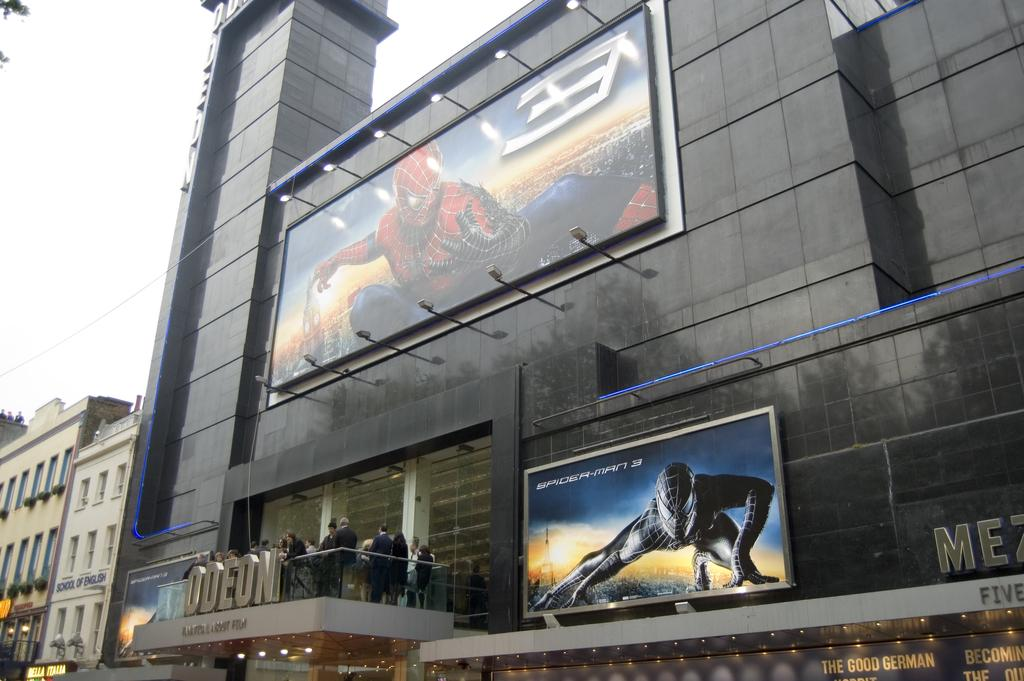What type of structures can be seen in the image? There are buildings in the image. Are there any people present in the image? Yes, there are persons standing in the image. What is on the board that is visible in the image? There is a board with an image in the image. What is visible at the top of the image? The sky is visible at the top of the image. Can you see any fangs on the persons in the image? There are no fangs visible on the persons in the image. Are there any roses growing on the buildings in the image? There is no mention of roses in the image; it only features buildings, persons, a board with an image, and the sky. 